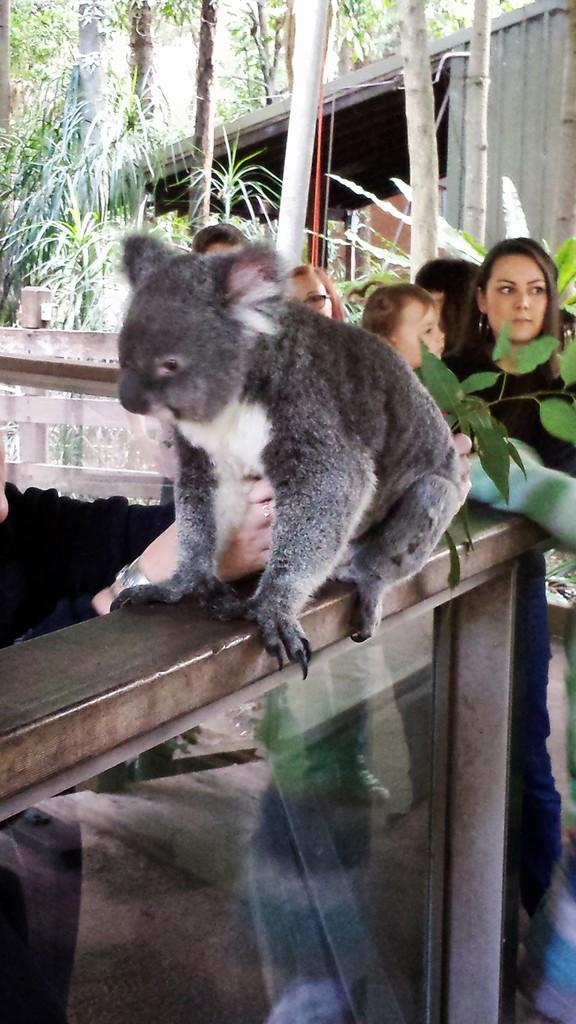In one or two sentences, can you explain what this image depicts? It is an animal in grey color, on the right side a woman is looking at that side. On the left side there are trees. 